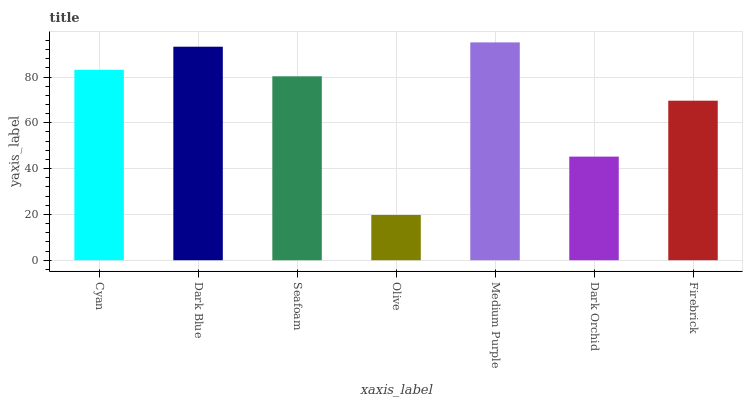Is Olive the minimum?
Answer yes or no. Yes. Is Medium Purple the maximum?
Answer yes or no. Yes. Is Dark Blue the minimum?
Answer yes or no. No. Is Dark Blue the maximum?
Answer yes or no. No. Is Dark Blue greater than Cyan?
Answer yes or no. Yes. Is Cyan less than Dark Blue?
Answer yes or no. Yes. Is Cyan greater than Dark Blue?
Answer yes or no. No. Is Dark Blue less than Cyan?
Answer yes or no. No. Is Seafoam the high median?
Answer yes or no. Yes. Is Seafoam the low median?
Answer yes or no. Yes. Is Dark Orchid the high median?
Answer yes or no. No. Is Dark Orchid the low median?
Answer yes or no. No. 